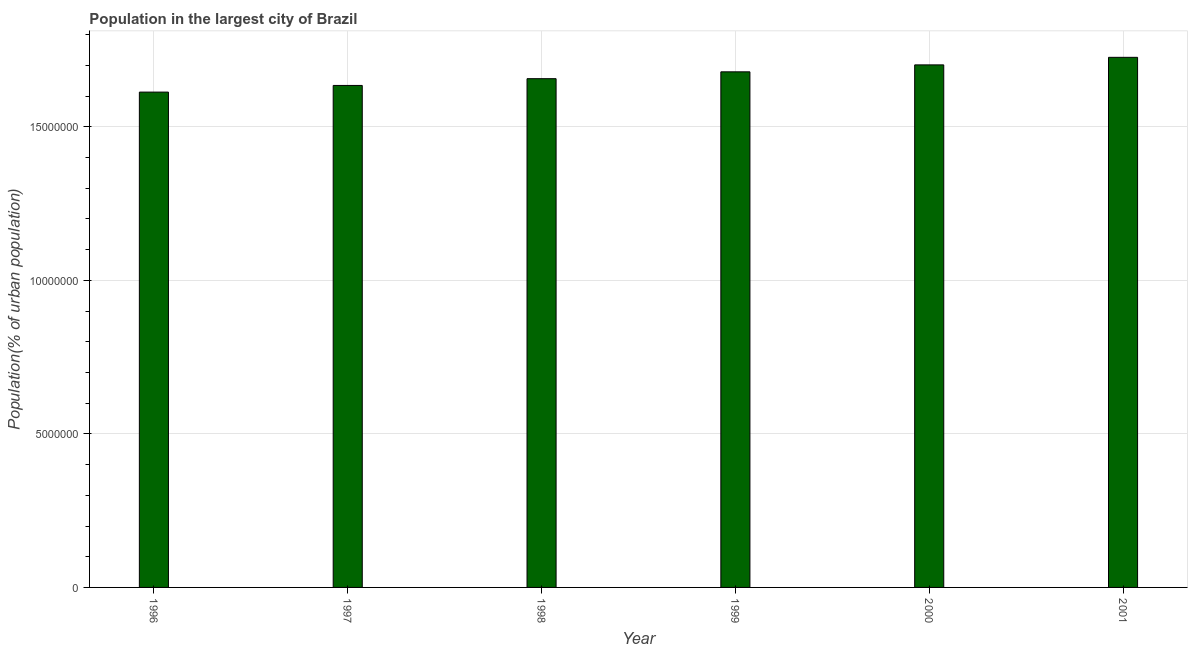What is the title of the graph?
Provide a short and direct response. Population in the largest city of Brazil. What is the label or title of the Y-axis?
Your answer should be compact. Population(% of urban population). What is the population in largest city in 1996?
Make the answer very short. 1.61e+07. Across all years, what is the maximum population in largest city?
Provide a short and direct response. 1.73e+07. Across all years, what is the minimum population in largest city?
Provide a succinct answer. 1.61e+07. In which year was the population in largest city minimum?
Ensure brevity in your answer.  1996. What is the sum of the population in largest city?
Keep it short and to the point. 1.00e+08. What is the difference between the population in largest city in 1996 and 1997?
Offer a very short reply. -2.17e+05. What is the average population in largest city per year?
Make the answer very short. 1.67e+07. What is the median population in largest city?
Make the answer very short. 1.67e+07. In how many years, is the population in largest city greater than 2000000 %?
Ensure brevity in your answer.  6. What is the ratio of the population in largest city in 1996 to that in 2001?
Offer a terse response. 0.93. Is the population in largest city in 1996 less than that in 2001?
Make the answer very short. Yes. What is the difference between the highest and the second highest population in largest city?
Your answer should be very brief. 2.46e+05. What is the difference between the highest and the lowest population in largest city?
Provide a short and direct response. 1.13e+06. Are all the bars in the graph horizontal?
Your answer should be compact. No. How many years are there in the graph?
Provide a short and direct response. 6. What is the Population(% of urban population) of 1996?
Your answer should be very brief. 1.61e+07. What is the Population(% of urban population) of 1997?
Offer a terse response. 1.63e+07. What is the Population(% of urban population) in 1998?
Your response must be concise. 1.66e+07. What is the Population(% of urban population) in 1999?
Your answer should be very brief. 1.68e+07. What is the Population(% of urban population) of 2000?
Your response must be concise. 1.70e+07. What is the Population(% of urban population) of 2001?
Make the answer very short. 1.73e+07. What is the difference between the Population(% of urban population) in 1996 and 1997?
Ensure brevity in your answer.  -2.17e+05. What is the difference between the Population(% of urban population) in 1996 and 1998?
Provide a succinct answer. -4.37e+05. What is the difference between the Population(% of urban population) in 1996 and 1999?
Provide a succinct answer. -6.60e+05. What is the difference between the Population(% of urban population) in 1996 and 2000?
Your response must be concise. -8.86e+05. What is the difference between the Population(% of urban population) in 1996 and 2001?
Offer a terse response. -1.13e+06. What is the difference between the Population(% of urban population) in 1997 and 1998?
Provide a short and direct response. -2.20e+05. What is the difference between the Population(% of urban population) in 1997 and 1999?
Keep it short and to the point. -4.43e+05. What is the difference between the Population(% of urban population) in 1997 and 2000?
Ensure brevity in your answer.  -6.69e+05. What is the difference between the Population(% of urban population) in 1997 and 2001?
Your answer should be very brief. -9.15e+05. What is the difference between the Population(% of urban population) in 1998 and 1999?
Keep it short and to the point. -2.23e+05. What is the difference between the Population(% of urban population) in 1998 and 2000?
Give a very brief answer. -4.49e+05. What is the difference between the Population(% of urban population) in 1998 and 2001?
Provide a short and direct response. -6.95e+05. What is the difference between the Population(% of urban population) in 1999 and 2000?
Your answer should be very brief. -2.26e+05. What is the difference between the Population(% of urban population) in 1999 and 2001?
Provide a succinct answer. -4.72e+05. What is the difference between the Population(% of urban population) in 2000 and 2001?
Give a very brief answer. -2.46e+05. What is the ratio of the Population(% of urban population) in 1996 to that in 1997?
Your answer should be compact. 0.99. What is the ratio of the Population(% of urban population) in 1996 to that in 2000?
Give a very brief answer. 0.95. What is the ratio of the Population(% of urban population) in 1996 to that in 2001?
Offer a very short reply. 0.93. What is the ratio of the Population(% of urban population) in 1997 to that in 1998?
Your answer should be very brief. 0.99. What is the ratio of the Population(% of urban population) in 1997 to that in 1999?
Offer a very short reply. 0.97. What is the ratio of the Population(% of urban population) in 1997 to that in 2001?
Keep it short and to the point. 0.95. What is the ratio of the Population(% of urban population) in 1999 to that in 2001?
Offer a terse response. 0.97. 